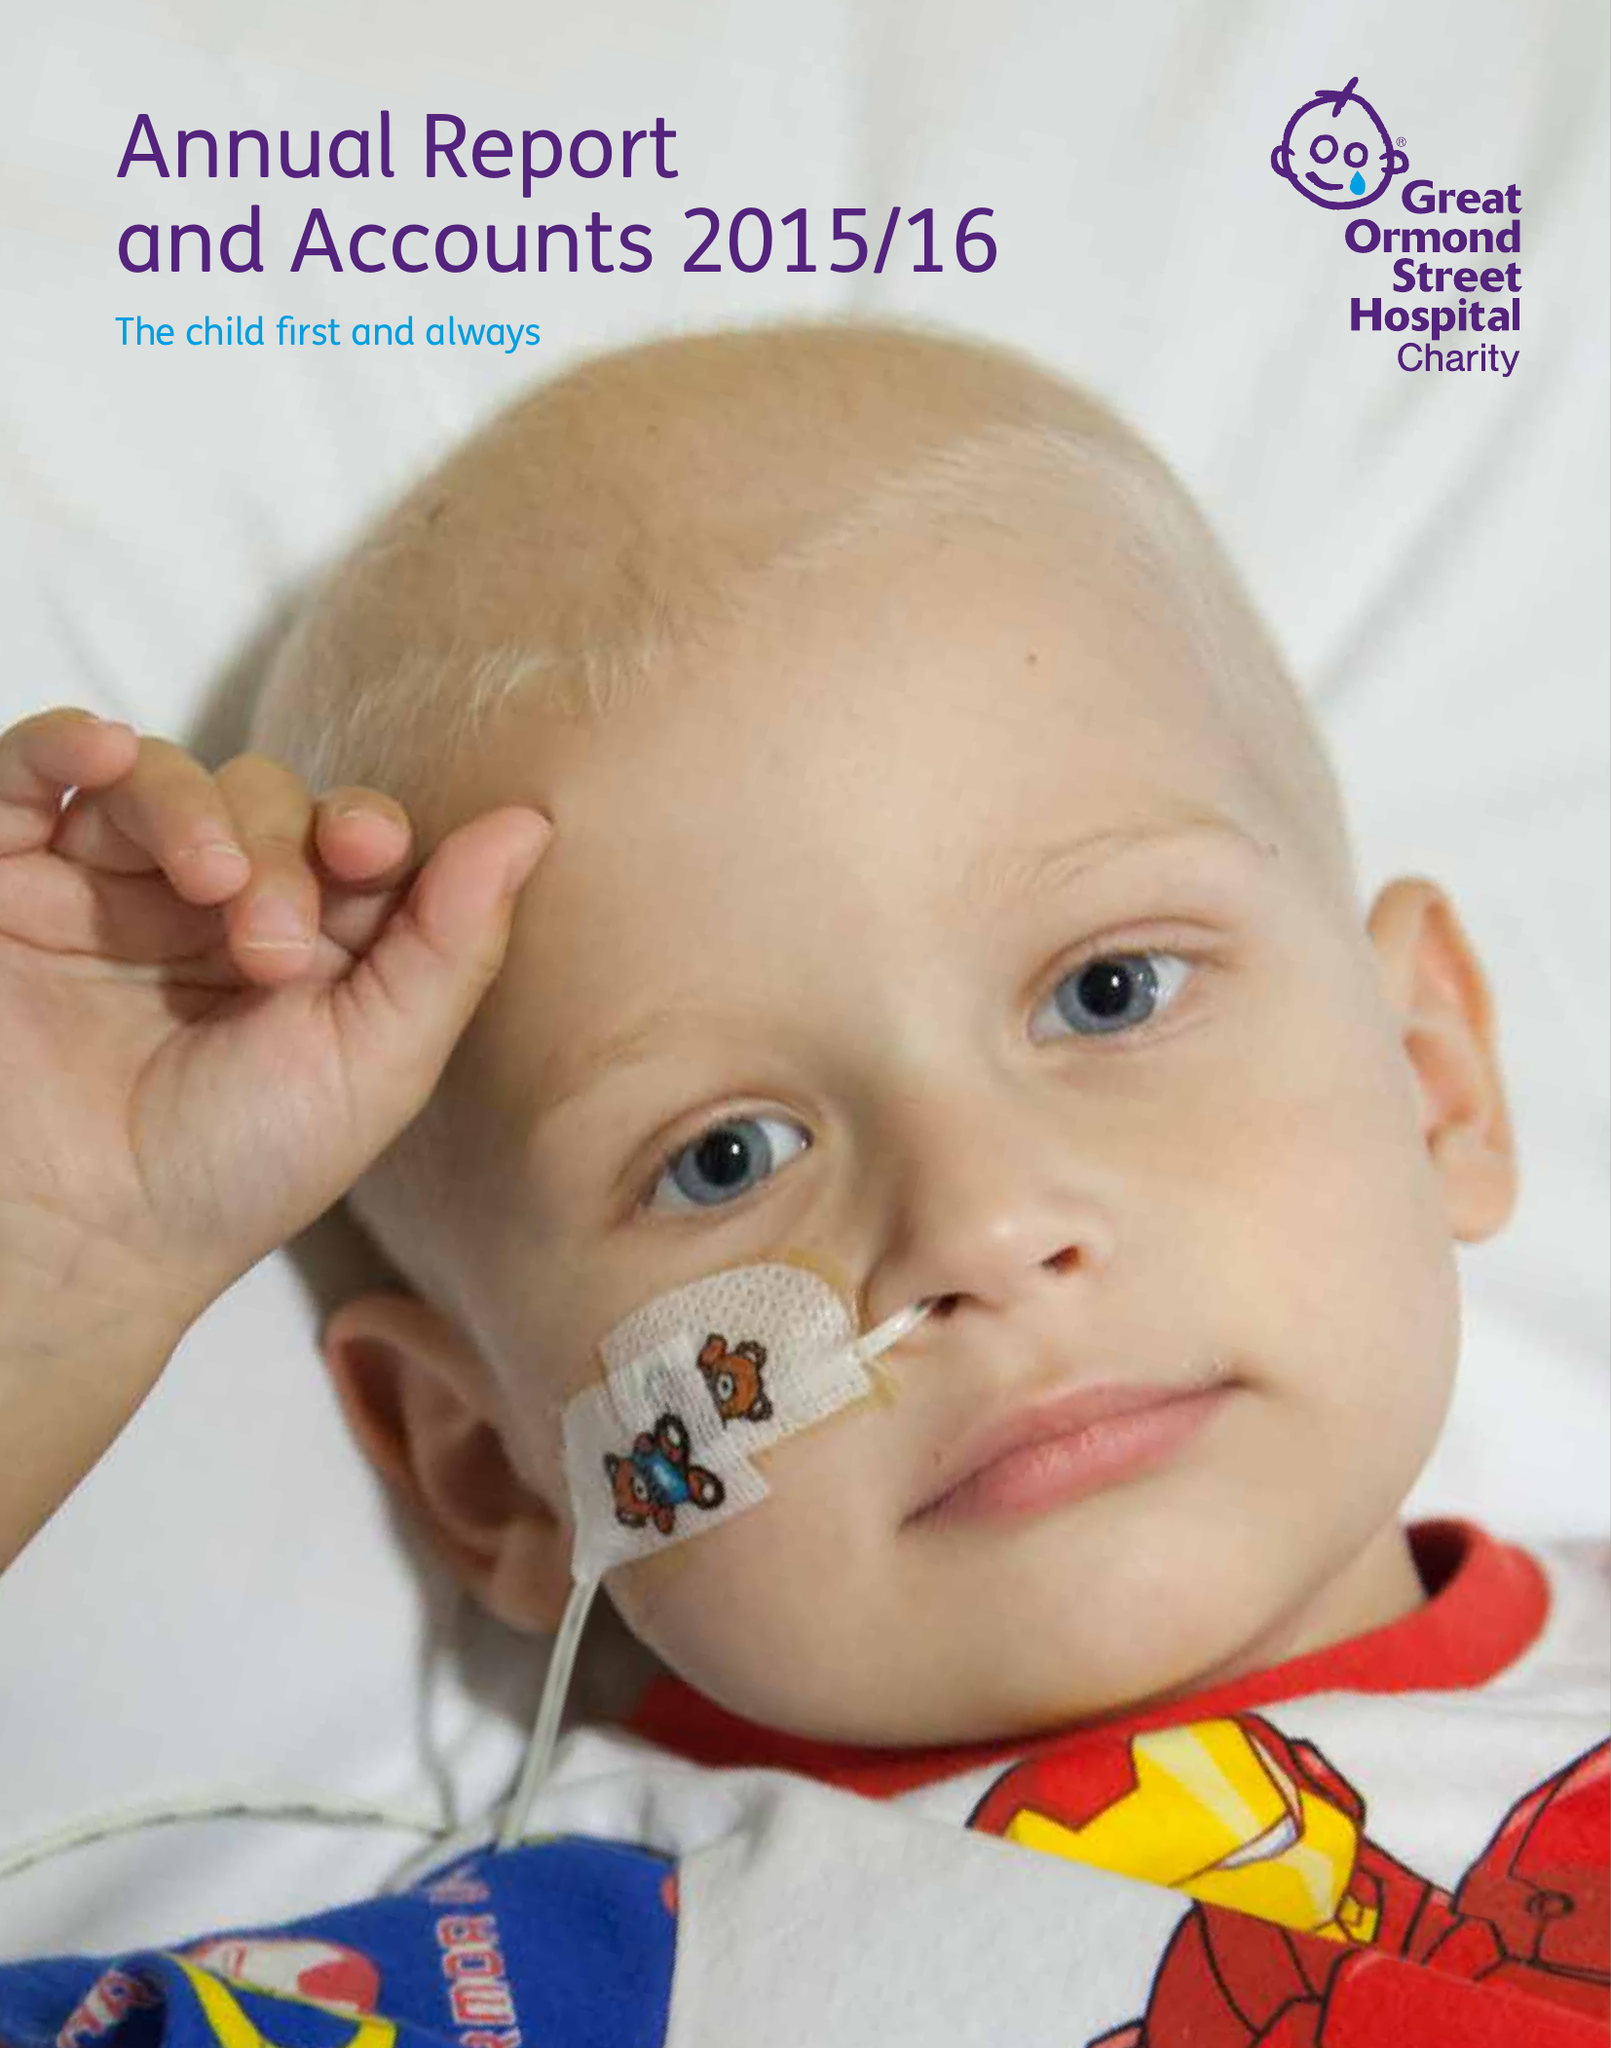What is the value for the address__postcode?
Answer the question using a single word or phrase. WC1N 1LE 